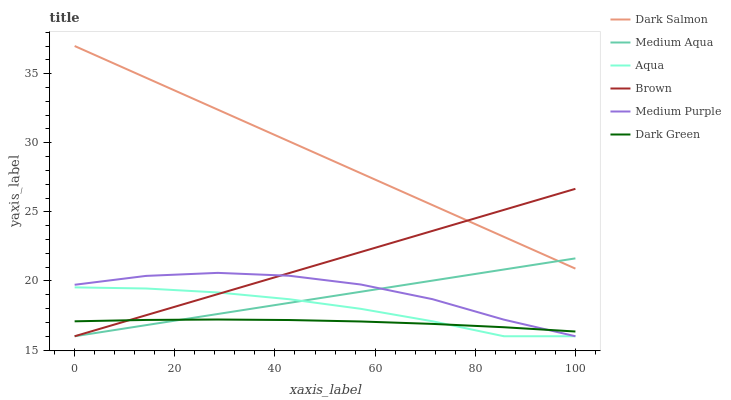Does Aqua have the minimum area under the curve?
Answer yes or no. No. Does Aqua have the maximum area under the curve?
Answer yes or no. No. Is Aqua the smoothest?
Answer yes or no. No. Is Aqua the roughest?
Answer yes or no. No. Does Dark Salmon have the lowest value?
Answer yes or no. No. Does Aqua have the highest value?
Answer yes or no. No. Is Medium Purple less than Dark Salmon?
Answer yes or no. Yes. Is Dark Salmon greater than Medium Purple?
Answer yes or no. Yes. Does Medium Purple intersect Dark Salmon?
Answer yes or no. No. 